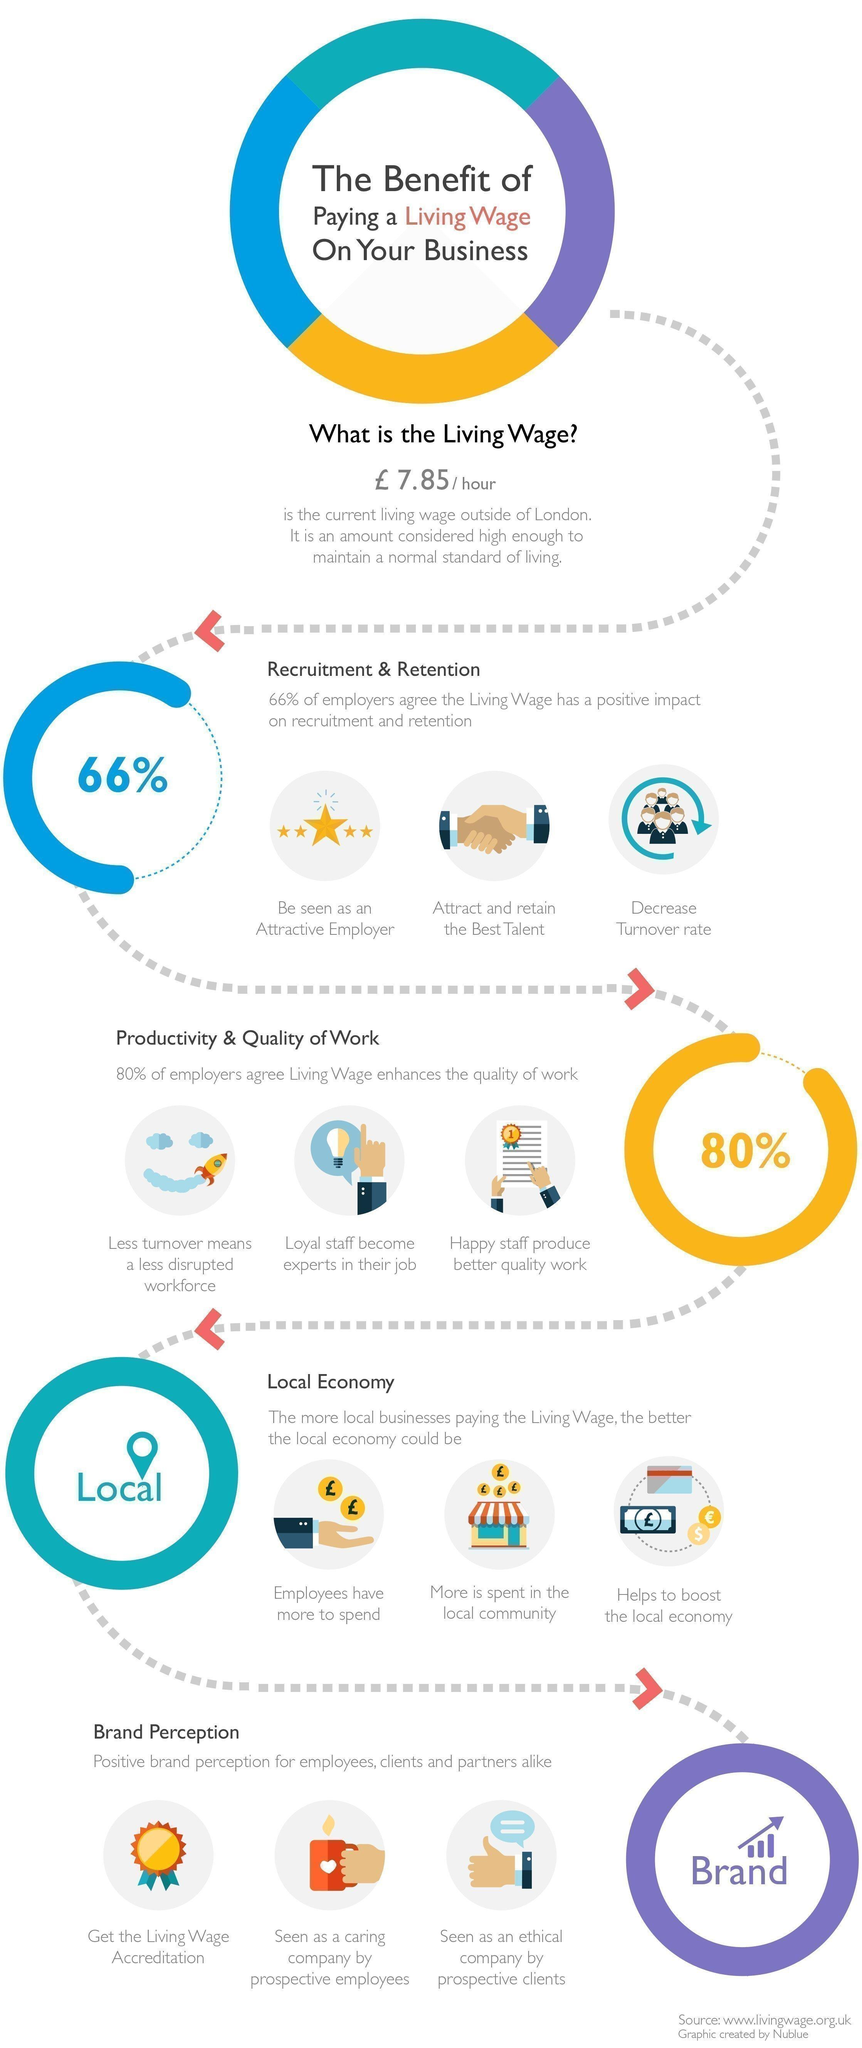Indicate a few pertinent items in this graphic. The third image displays a total of 5 stars. The third image shows stars, and in that image, the color of the stars is yellow. The living wage in London is currently £7.85 per hour. The image shown for living wage accreditation is a medal, not a house, cup, or star. The term used for the amount considered high enough to maintain a normal standard of living is 'living wage.' 